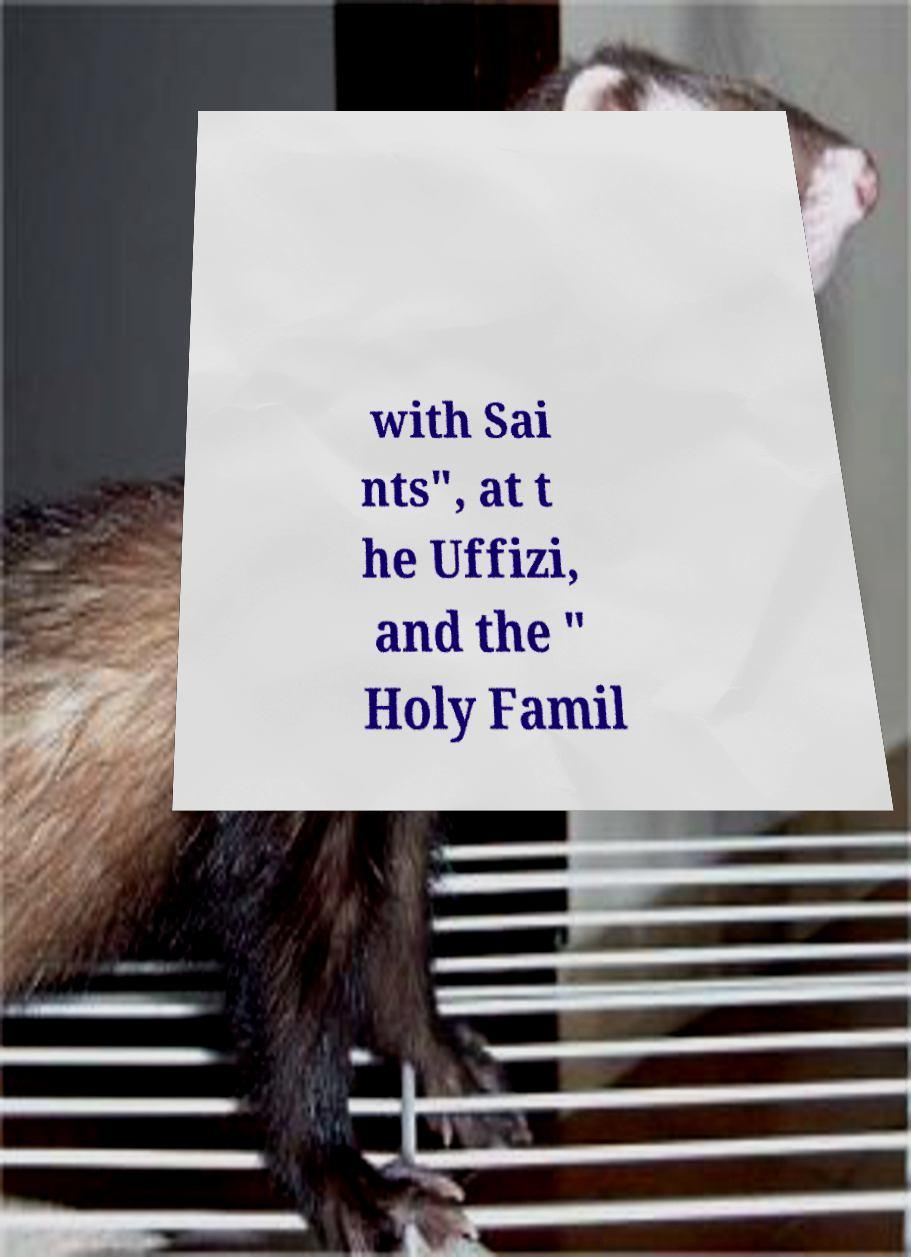Please read and relay the text visible in this image. What does it say? with Sai nts", at t he Uffizi, and the " Holy Famil 